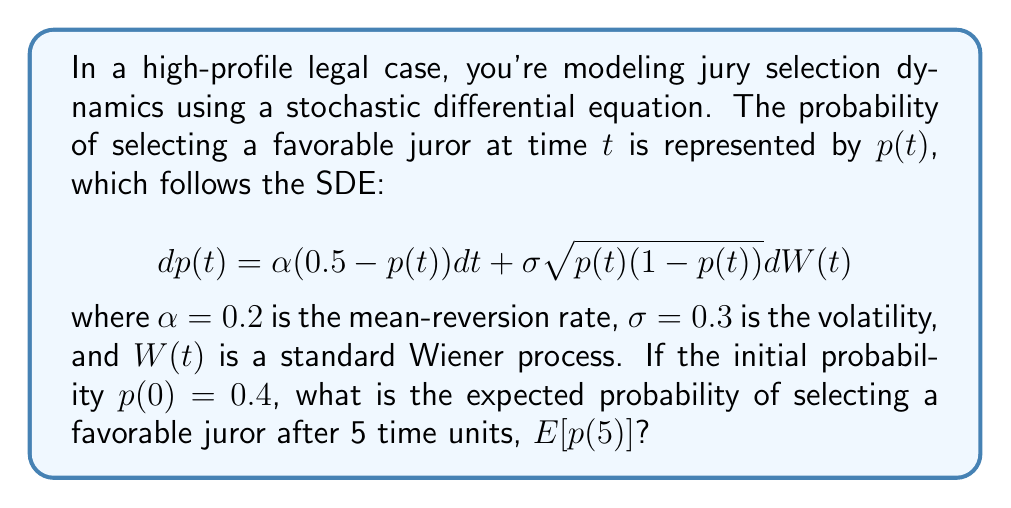Teach me how to tackle this problem. To solve this problem, we need to follow these steps:

1) The given SDE is in the form of a mean-reverting square-root process, similar to the Cox-Ingersoll-Ross model.

2) For this type of SDE, the expected value at time $t$, given an initial value $p(0)$, is:

   $$E[p(t)|p(0)] = 0.5 + (p(0) - 0.5)e^{-\alpha t}$$

3) We are given:
   - $p(0) = 0.4$
   - $\alpha = 0.2$
   - $t = 5$

4) Let's substitute these values into the equation:

   $$E[p(5)|p(0) = 0.4] = 0.5 + (0.4 - 0.5)e^{-0.2 \cdot 5}$$

5) Simplify:
   $$E[p(5)|p(0) = 0.4] = 0.5 - 0.1e^{-1}$$

6) Calculate:
   $$E[p(5)|p(0) = 0.4] = 0.5 - 0.1 \cdot 0.3679 \approx 0.4632$$

Therefore, the expected probability of selecting a favorable juror after 5 time units is approximately 0.4632 or 46.32%.
Answer: 0.4632 